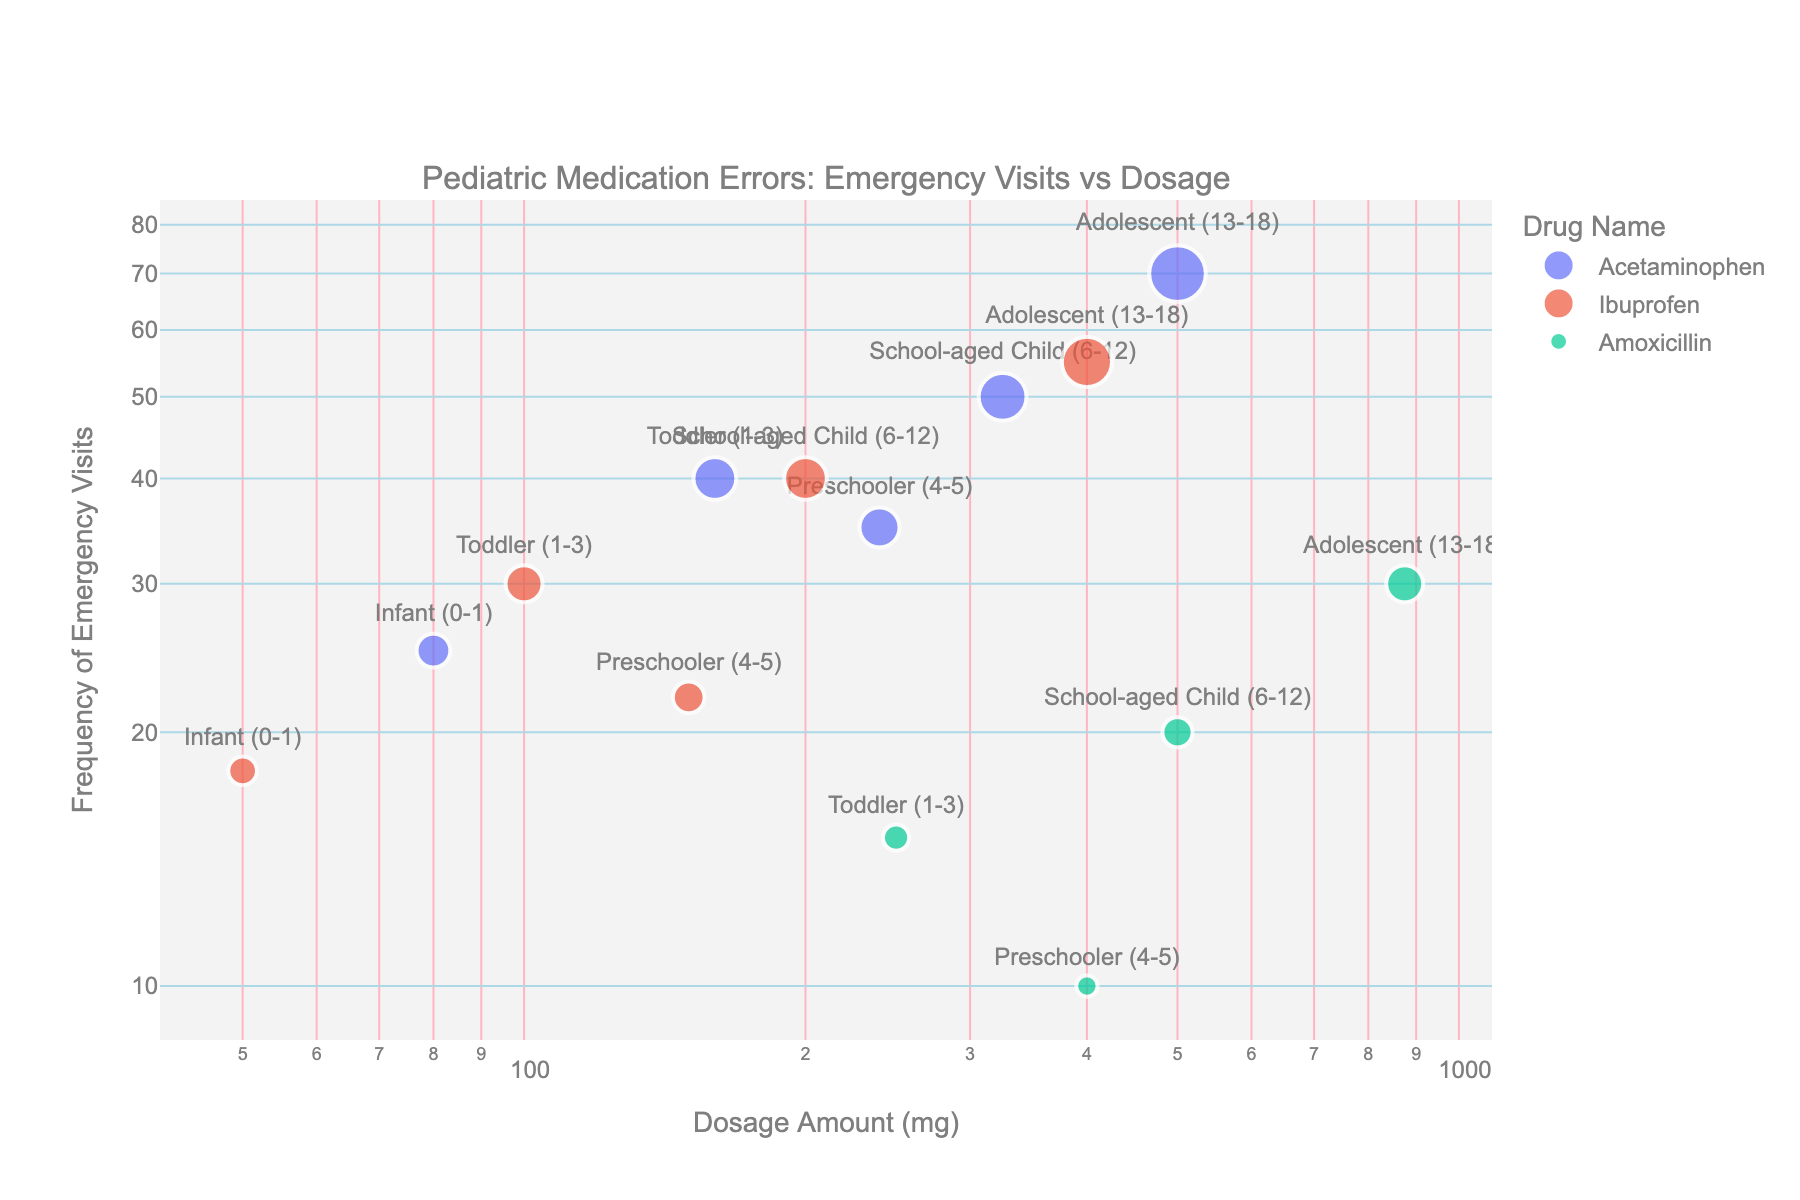What's the title of the plot? The title is stated above the scatter plot.
Answer: Pediatric Medication Errors: Emergency Visits vs Dosage Which axis represents the Dosage Amount? The x-axis is labeled as "Dosage Amount (mg)" and represents the Dosage Amount.
Answer: x-axis Which drug has the highest frequency of emergency visits for Adolescents (13-18)? By looking at the data points for Adolescents (13-18), Acetaminophen has the highest frequency with 70 emergency visits.
Answer: Acetaminophen What is the dosage amount for Ibuprofen in toddlers (1-3)? By identifying the data point for Ibuprofen under the label for toddlers, the dosage amount shown is 100 mg.
Answer: 100 mg Is there an age group that shows a higher frequency of emergency visits compared to others? The data points for Adolescents (13-18) stand out with consistently higher frequencies of emergency visits for multiple drugs.
Answer: Adolescents (13-18) Which drug has the lowest dosage amount that results in emergency visits? By comparing the x-axis values (log scale), Ibuprofen in infants (0-1) has the lowest dosage amount at 50 mg.
Answer: Ibuprofen in infants For Acetaminophen, how does the dosage amount change from toddlers to school-aged children? For toddlers, the dosage is 160 mg and for school-aged children, it is 325 mg. The increase in dosage is 325 mg - 160 mg = 165 mg.
Answer: Increases by 165 mg How do emergency visits for Amoxicillin compare between toddlers and preschoolers? For toddlers, the frequency of emergency visits is 15, and for preschoolers, it is 10. This shows a decrease of 5 visits.
Answer: Decrease by 5 Which age group has a dosage amount of 400 mg for any drug? From the scatter plot, Adolescents (13-18) using Ibuprofen and Preschoolers (4-5) using Amoxicillin show a dosage amount of 400 mg.
Answer: Adolescents (13-18) and Preschoolers (4-5) Do drugs with higher dosage amounts always correlate to higher frequencies of emergency visits? By examining the scatter plot closely, there isn't a consistent pattern suggesting that higher dosage amounts always lead to higher frequencies of emergency visits, so it varies by drug and age group.
Answer: No 